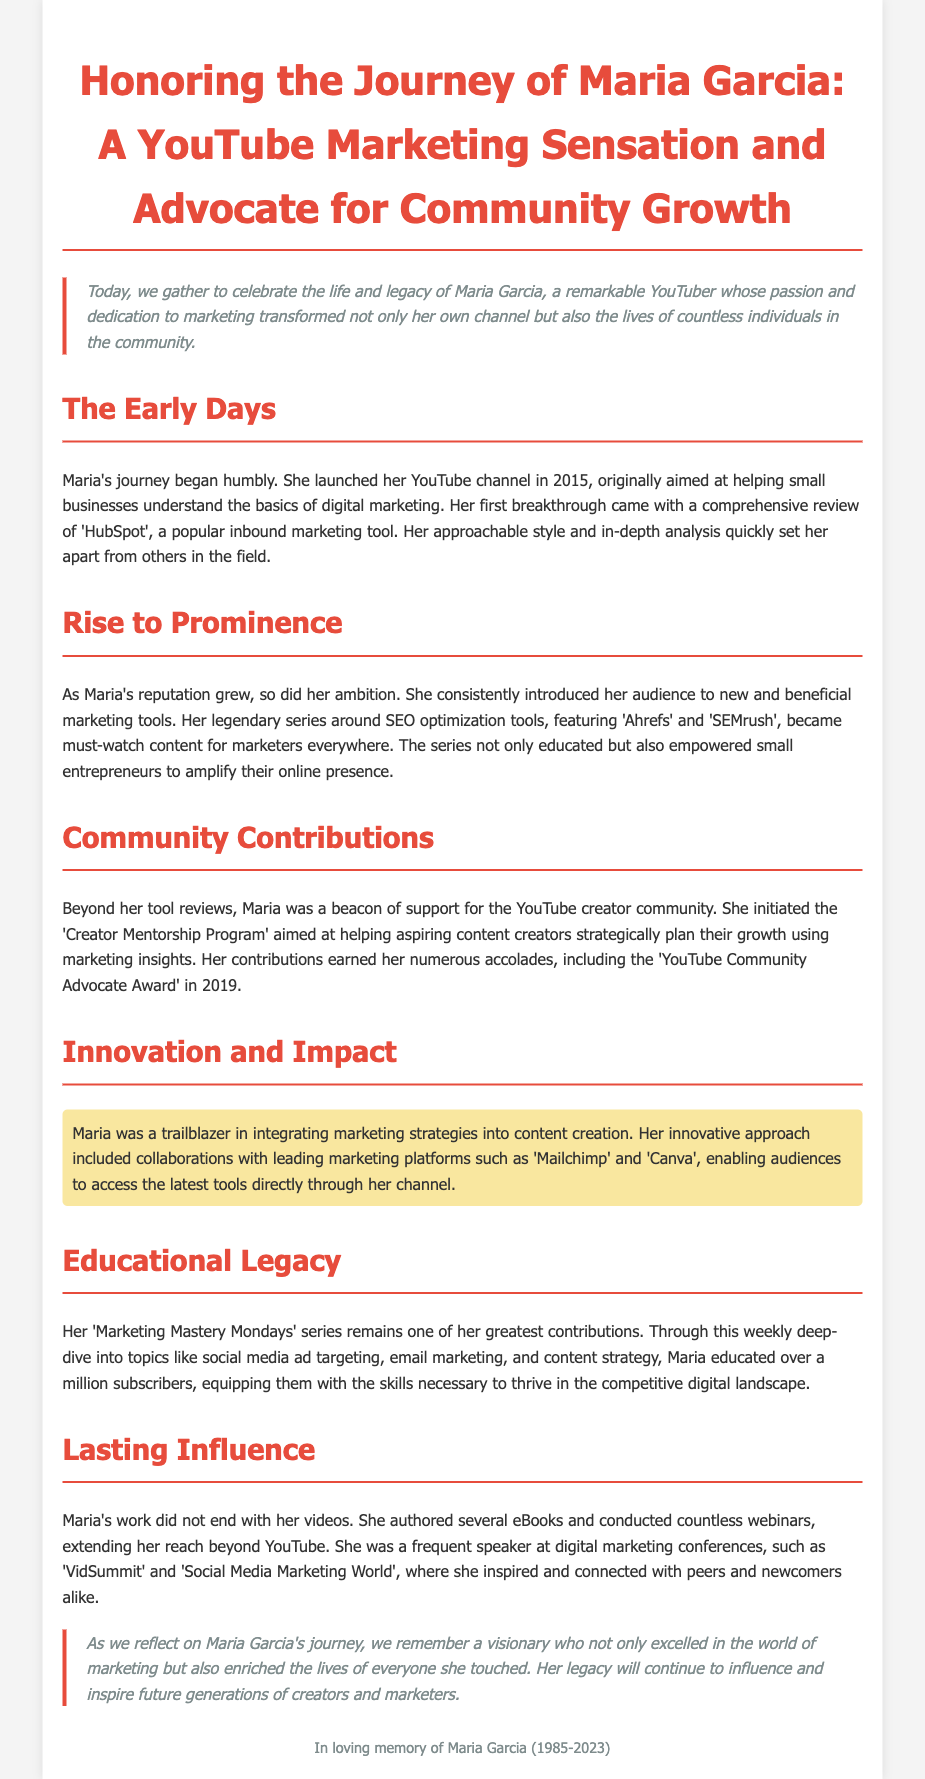What year did Maria launch her YouTube channel? The document states that Maria launched her YouTube channel in 2015, which is a specific year.
Answer: 2015 What was Maria's first breakthrough review? The document mentions that her first breakthrough came with a review of 'HubSpot', highlighting this particular marketing tool.
Answer: HubSpot Which award did Maria receive in 2019? According to the document, Maria earned the 'YouTube Community Advocate Award' in 2019, marking a significant recognition in her career.
Answer: YouTube Community Advocate Award What was the focus of Maria's 'Marketing Mastery Mondays' series? The document indicates that this series was aimed at deep-diving into topics like social media ad targeting, email marketing, and content strategy.
Answer: Marketing education How many subscribers did Maria educate through her series? The document states that Maria educated over a million subscribers, quantifying her impact in numbers.
Answer: over a million Who did Maria collaborate with in her innovative approach? The document refers to collaborations with 'Mailchimp' and 'Canva', identifying these platforms as part of her innovative marketing strategy.
Answer: Mailchimp and Canva What community program did Maria initiate? The document mentions the 'Creator Mentorship Program' as a specific program aimed at supporting aspiring content creators.
Answer: Creator Mentorship Program What year was Maria born? The document provides the birth year of Maria, stating she was born in 1985.
Answer: 1985 What type of events did Maria frequently speak at? The document lists digital marketing conferences, indicating the type of events where Maria was a speaker.
Answer: Digital marketing conferences 